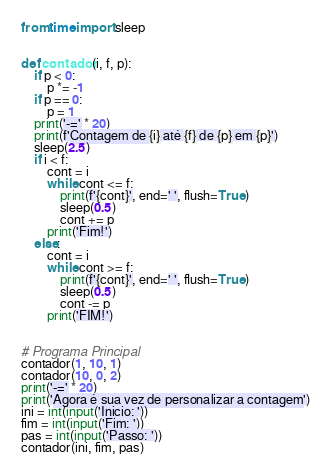Convert code to text. <code><loc_0><loc_0><loc_500><loc_500><_Python_>from time import sleep


def contador(i, f, p):
    if p < 0:
        p *= -1
    if p == 0:
        p = 1
    print('-=' * 20)
    print(f'Contagem de {i} até {f} de {p} em {p}')
    sleep(2.5)
    if i < f:
        cont = i
        while cont <= f:
            print(f'{cont}', end=' ', flush=True)
            sleep(0.5)
            cont += p
        print('Fim!')
    else:
        cont = i
        while cont >= f:
            print(f'{cont}', end=' ', flush=True)
            sleep(0.5)
            cont -= p
        print('FIM!')


# Programa Principal
contador(1, 10, 1)
contador(10, 0, 2)
print('-=' * 20)
print('Agora é sua vez de personalizar a contagem')
ini = int(input('Inicio: '))
fim = int(input('Fim: '))
pas = int(input('Passo: '))
contador(ini, fim, pas)
</code> 